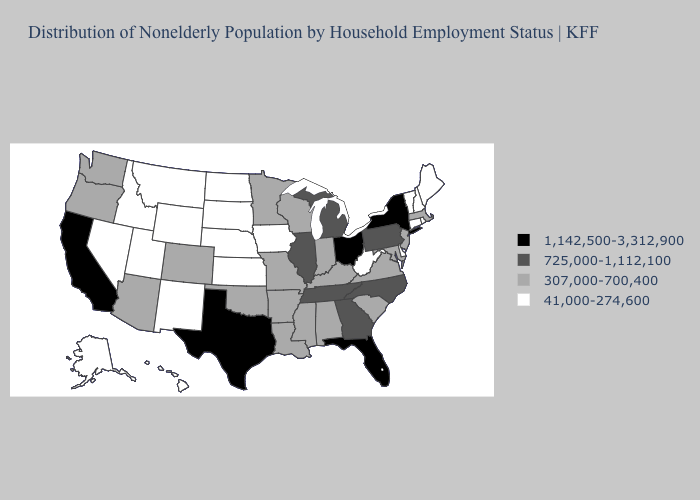Name the states that have a value in the range 725,000-1,112,100?
Concise answer only. Georgia, Illinois, Michigan, North Carolina, Pennsylvania, Tennessee. Does North Dakota have the lowest value in the MidWest?
Concise answer only. Yes. What is the lowest value in states that border Louisiana?
Concise answer only. 307,000-700,400. Does Ohio have the highest value in the MidWest?
Write a very short answer. Yes. Does Ohio have the same value as Texas?
Be succinct. Yes. Does Massachusetts have a higher value than Iowa?
Give a very brief answer. Yes. Name the states that have a value in the range 725,000-1,112,100?
Write a very short answer. Georgia, Illinois, Michigan, North Carolina, Pennsylvania, Tennessee. Does the first symbol in the legend represent the smallest category?
Concise answer only. No. Is the legend a continuous bar?
Concise answer only. No. Does Montana have the same value as Alaska?
Answer briefly. Yes. Which states have the highest value in the USA?
Be succinct. California, Florida, New York, Ohio, Texas. Does the first symbol in the legend represent the smallest category?
Write a very short answer. No. Among the states that border New York , does New Jersey have the highest value?
Concise answer only. No. What is the lowest value in the MidWest?
Keep it brief. 41,000-274,600. Which states have the lowest value in the USA?
Give a very brief answer. Alaska, Connecticut, Delaware, Hawaii, Idaho, Iowa, Kansas, Maine, Montana, Nebraska, Nevada, New Hampshire, New Mexico, North Dakota, Rhode Island, South Dakota, Utah, Vermont, West Virginia, Wyoming. 